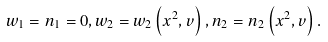<formula> <loc_0><loc_0><loc_500><loc_500>w _ { 1 } = n _ { 1 } = 0 , w _ { 2 } = w _ { 2 } \left ( x ^ { 2 } , v \right ) , n _ { 2 } = n _ { 2 } \left ( x ^ { 2 } , v \right ) .</formula> 